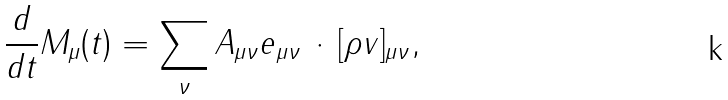<formula> <loc_0><loc_0><loc_500><loc_500>\frac { d } { d t } M _ { \mu } ( t ) = \sum _ { \nu } A _ { \mu \nu } { e } _ { \mu \nu } \, \cdot \, [ \rho { v } ] _ { \mu \nu } ,</formula> 